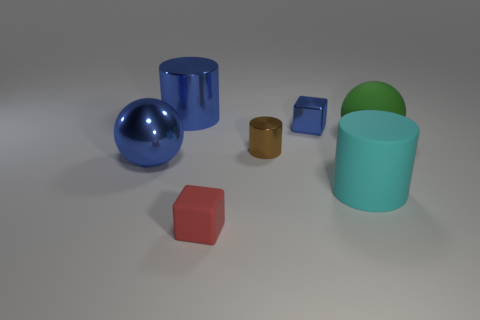There is a tiny shiny thing that is behind the tiny metallic cylinder; is it the same color as the big sphere on the left side of the big cyan rubber object?
Ensure brevity in your answer.  Yes. Do the cyan rubber thing and the small brown metallic thing have the same shape?
Offer a terse response. Yes. Is the small cube right of the red matte cube made of the same material as the tiny brown cylinder?
Ensure brevity in your answer.  Yes. There is a object that is to the right of the tiny brown object and left of the matte cylinder; what is its shape?
Your answer should be very brief. Cube. Are there any tiny rubber things on the right side of the shiny cylinder that is in front of the blue cylinder?
Offer a very short reply. No. What number of other objects are the same material as the green ball?
Your response must be concise. 2. There is a metallic thing that is behind the blue cube; is it the same shape as the large thing in front of the blue ball?
Provide a succinct answer. Yes. Are the small red thing and the small blue thing made of the same material?
Your answer should be very brief. No. What size is the cube that is in front of the big thing that is on the left side of the large metal object behind the blue ball?
Give a very brief answer. Small. How many other things are there of the same color as the tiny metallic block?
Keep it short and to the point. 2. 